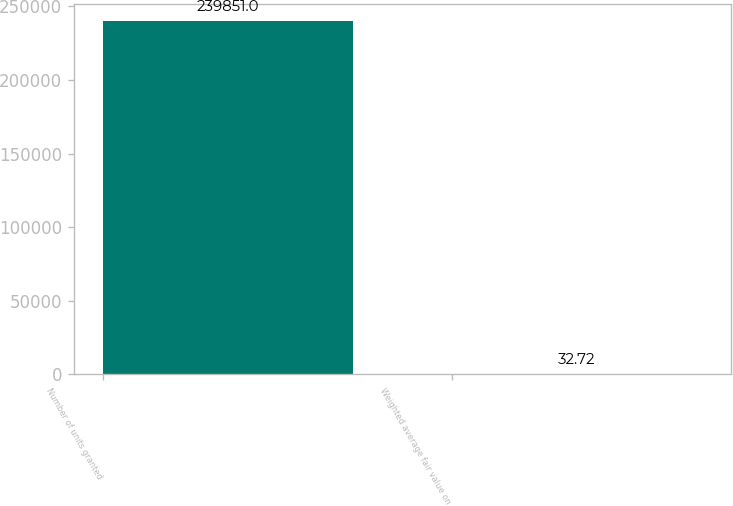<chart> <loc_0><loc_0><loc_500><loc_500><bar_chart><fcel>Number of units granted<fcel>Weighted average fair value on<nl><fcel>239851<fcel>32.72<nl></chart> 